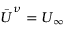Convert formula to latex. <formula><loc_0><loc_0><loc_500><loc_500>\bar { U } ^ { \nu } = U _ { \infty }</formula> 